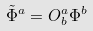Convert formula to latex. <formula><loc_0><loc_0><loc_500><loc_500>\tilde { \Phi } ^ { a } = O ^ { a } _ { b } \Phi ^ { b }</formula> 